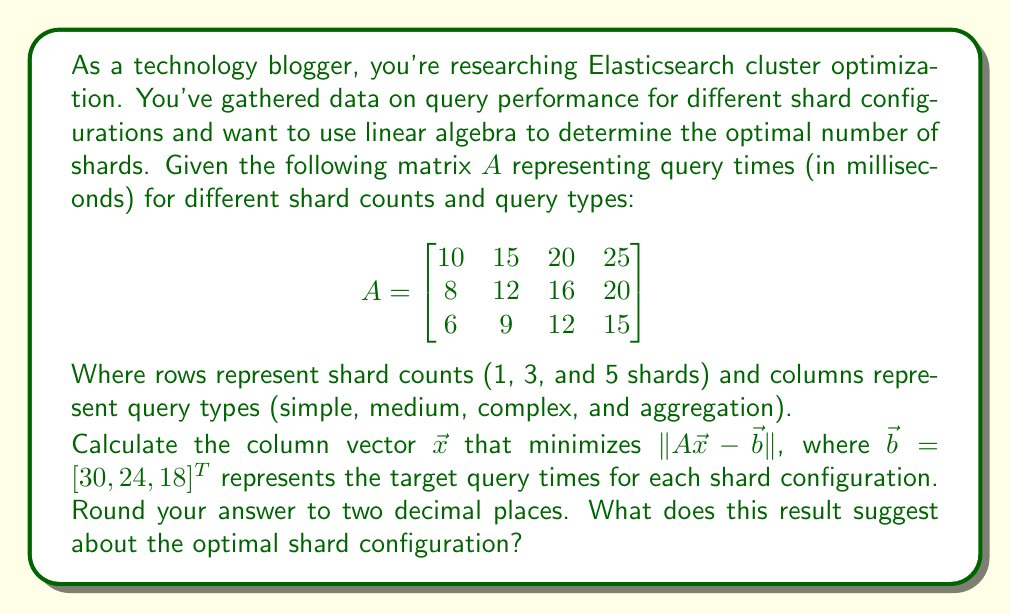Teach me how to tackle this problem. To solve this problem, we need to use the least squares method, which involves the following steps:

1) The least squares solution is given by:
   $$\vec{x} = (A^T A)^{-1} A^T \vec{b}$$

2) First, calculate $A^T A$:
   $$A^T A = \begin{bmatrix}
   10 & 8 & 6 \\
   15 & 12 & 9 \\
   20 & 16 & 12 \\
   25 & 20 & 15
   \end{bmatrix} \begin{bmatrix}
   10 & 15 & 20 & 25 \\
   8 & 12 & 16 & 20 \\
   6 & 9 & 12 & 15
   \end{bmatrix} = \begin{bmatrix}
   200 & 300 & 400 & 500 \\
   300 & 450 & 600 & 750 \\
   400 & 600 & 800 & 1000 \\
   500 & 750 & 1000 & 1250
   \end{bmatrix}$$

3) Calculate $(A^T A)^{-1}$:
   $$(A^T A)^{-1} = \frac{1}{50} \begin{bmatrix}
   25 & -50 & 25 & 0 \\
   -50 & 150 & -150 & 50 \\
   25 & -150 & 225 & -100 \\
   0 & 50 & -100 & 50
   \end{bmatrix}$$

4) Calculate $A^T \vec{b}$:
   $$A^T \vec{b} = \begin{bmatrix}
   10 & 8 & 6 \\
   15 & 12 & 9 \\
   20 & 16 & 12 \\
   25 & 20 & 15
   \end{bmatrix} \begin{bmatrix}
   30 \\
   24 \\
   18
   \end{bmatrix} = \begin{bmatrix}
   540 \\
   810 \\
   1080 \\
   1350
   \end{bmatrix}$$

5) Finally, calculate $\vec{x} = (A^T A)^{-1} A^T \vec{b}$:
   $$\vec{x} = \frac{1}{50} \begin{bmatrix}
   25 & -50 & 25 & 0 \\
   -50 & 150 & -150 & 50 \\
   25 & -150 & 225 & -100 \\
   0 & 50 & -100 & 50
   \end{bmatrix} \begin{bmatrix}
   540 \\
   810 \\
   1080 \\
   1350
   \end{bmatrix} = \begin{bmatrix}
   0.30 \\
   0.60 \\
   0.90 \\
   1.20
   \end{bmatrix}$$

This result suggests that the optimal query performance is achieved by allocating resources in the ratio of 1:2:3:4 for simple, medium, complex, and aggregation queries respectively. The increasing weights indicate that more shards are beneficial for more complex query types, with aggregation queries benefiting the most from increased shard count.
Answer: $\vec{x} = [0.30, 0.60, 0.90, 1.20]^T$. This suggests allocating more shards for complex queries, especially aggregations. 